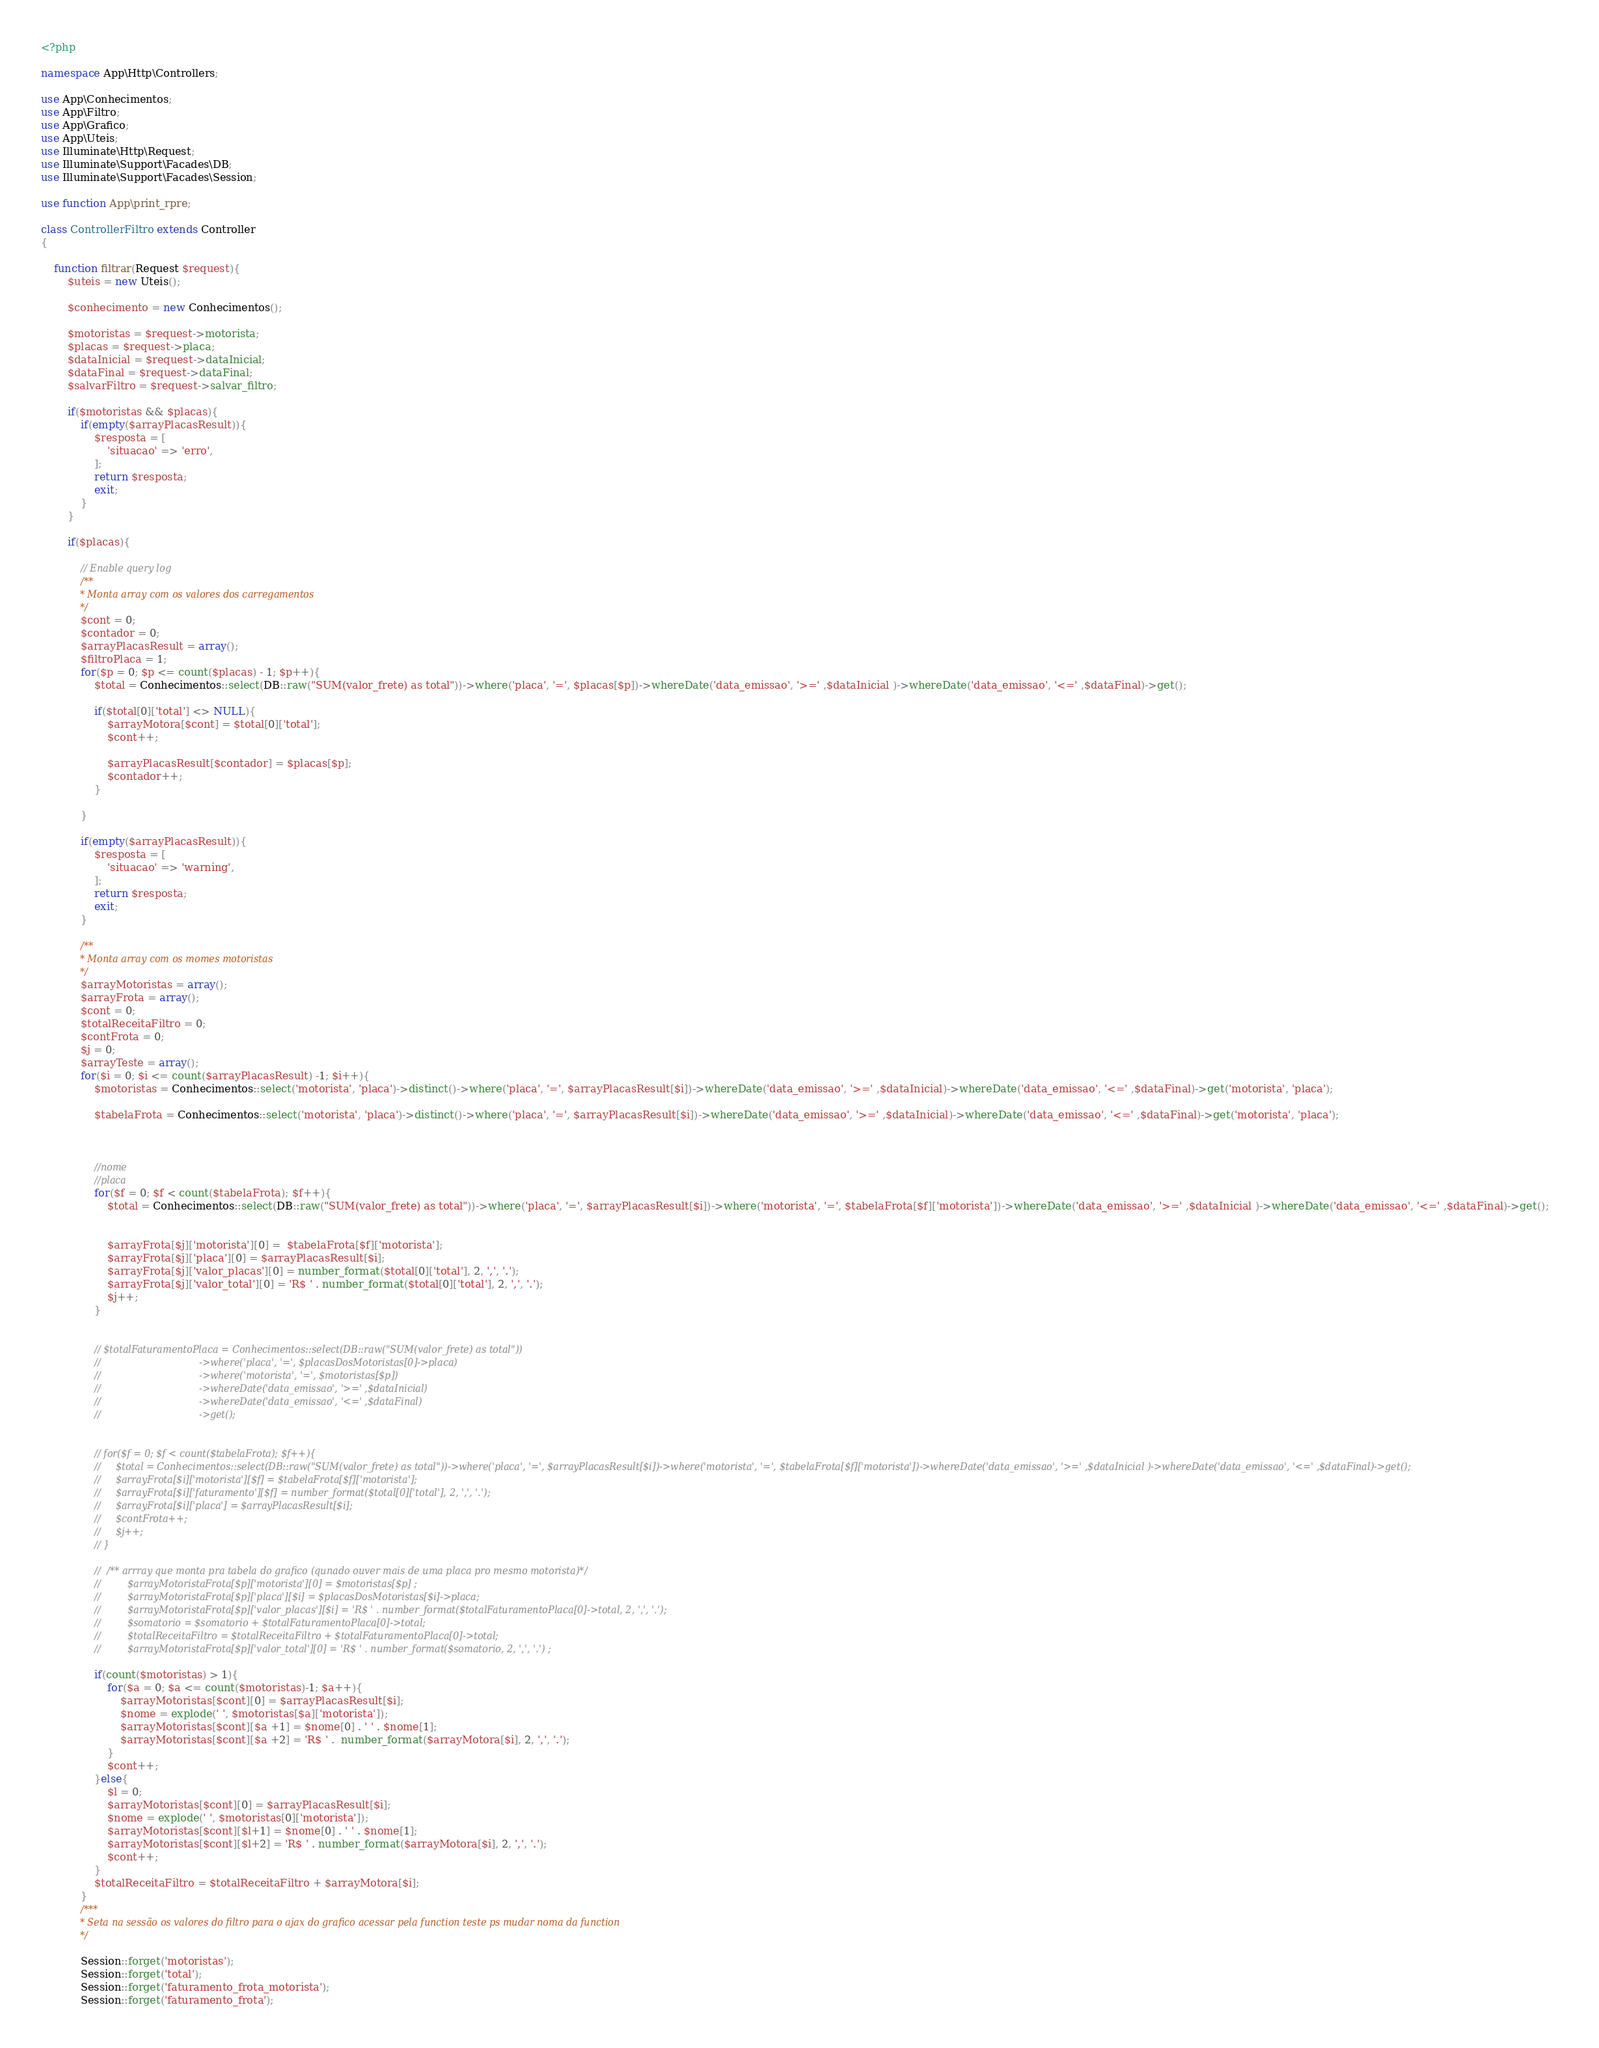Convert code to text. <code><loc_0><loc_0><loc_500><loc_500><_PHP_><?php

namespace App\Http\Controllers;

use App\Conhecimentos;
use App\Filtro;
use App\Grafico;
use App\Uteis;
use Illuminate\Http\Request;
use Illuminate\Support\Facades\DB;
use Illuminate\Support\Facades\Session;

use function App\print_rpre;

class ControllerFiltro extends Controller
{

    function filtrar(Request $request){
        $uteis = new Uteis();

        $conhecimento = new Conhecimentos();

        $motoristas = $request->motorista;
        $placas = $request->placa;
        $dataInicial = $request->dataInicial;
        $dataFinal = $request->dataFinal;
        $salvarFiltro = $request->salvar_filtro;

        if($motoristas && $placas){
            if(empty($arrayPlacasResult)){
                $resposta = [
                    'situacao' => 'erro',
                ];
                return $resposta;
                exit;
            }
        }

        if($placas){

            // Enable query log
            /**
             * Monta array com os valores dos carregamentos
             */
            $cont = 0;
            $contador = 0;
            $arrayPlacasResult = array();
            $filtroPlaca = 1;
            for($p = 0; $p <= count($placas) - 1; $p++){
                $total = Conhecimentos::select(DB::raw("SUM(valor_frete) as total"))->where('placa', '=', $placas[$p])->whereDate('data_emissao', '>=' ,$dataInicial )->whereDate('data_emissao', '<=' ,$dataFinal)->get();

                if($total[0]['total'] <> NULL){
                    $arrayMotora[$cont] = $total[0]['total'];
                    $cont++;

                    $arrayPlacasResult[$contador] = $placas[$p];
                    $contador++;
                }

            }

            if(empty($arrayPlacasResult)){
                $resposta = [
                    'situacao' => 'warning',
                ];
                return $resposta;
                exit;
            }

            /**
             * Monta array com os momes motoristas
             */
            $arrayMotoristas = array();
            $arrayFrota = array();
            $cont = 0;
            $totalReceitaFiltro = 0;
            $contFrota = 0;
            $j = 0;
            $arrayTeste = array();
            for($i = 0; $i <= count($arrayPlacasResult) -1; $i++){
                $motoristas = Conhecimentos::select('motorista', 'placa')->distinct()->where('placa', '=', $arrayPlacasResult[$i])->whereDate('data_emissao', '>=' ,$dataInicial)->whereDate('data_emissao', '<=' ,$dataFinal)->get('motorista', 'placa');

                $tabelaFrota = Conhecimentos::select('motorista', 'placa')->distinct()->where('placa', '=', $arrayPlacasResult[$i])->whereDate('data_emissao', '>=' ,$dataInicial)->whereDate('data_emissao', '<=' ,$dataFinal)->get('motorista', 'placa');



                //nome
                //placa
                for($f = 0; $f < count($tabelaFrota); $f++){
                    $total = Conhecimentos::select(DB::raw("SUM(valor_frete) as total"))->where('placa', '=', $arrayPlacasResult[$i])->where('motorista', '=', $tabelaFrota[$f]['motorista'])->whereDate('data_emissao', '>=' ,$dataInicial )->whereDate('data_emissao', '<=' ,$dataFinal)->get();


                    $arrayFrota[$j]['motorista'][0] =  $tabelaFrota[$f]['motorista'];
                    $arrayFrota[$j]['placa'][0] = $arrayPlacasResult[$i];
                    $arrayFrota[$j]['valor_placas'][0] = number_format($total[0]['total'], 2, ',', '.');
                    $arrayFrota[$j]['valor_total'][0] = 'R$ ' . number_format($total[0]['total'], 2, ',', '.');
                    $j++;
                }


                // $totalFaturamentoPlaca = Conhecimentos::select(DB::raw("SUM(valor_frete) as total"))
                //                                 ->where('placa', '=', $placasDosMotoristas[0]->placa)
                //                                 ->where('motorista', '=', $motoristas[$p])
                //                                 ->whereDate('data_emissao', '>=' ,$dataInicial)
                //                                 ->whereDate('data_emissao', '<=' ,$dataFinal)
                //                                 ->get();


                // for($f = 0; $f < count($tabelaFrota); $f++){
                //     $total = Conhecimentos::select(DB::raw("SUM(valor_frete) as total"))->where('placa', '=', $arrayPlacasResult[$i])->where('motorista', '=', $tabelaFrota[$f]['motorista'])->whereDate('data_emissao', '>=' ,$dataInicial )->whereDate('data_emissao', '<=' ,$dataFinal)->get();
                //     $arrayFrota[$i]['motorista'][$f] = $tabelaFrota[$f]['motorista'];
                //     $arrayFrota[$i]['faturamento'][$f] = number_format($total[0]['total'], 2, ',', '.');
                //     $arrayFrota[$i]['placa'] = $arrayPlacasResult[$i];
                //     $contFrota++;
                //     $j++;
                // }

                //  /** arrray que monta pra tabela do grafico (qunado ouver mais de uma placa pro mesmo motorista)*/
                //         $arrayMotoristaFrota[$p]['motorista'][0] = $motoristas[$p] ;
                //         $arrayMotoristaFrota[$p]['placa'][$i] = $placasDosMotoristas[$i]->placa;
                //         $arrayMotoristaFrota[$p]['valor_placas'][$i] = 'R$ ' . number_format($totalFaturamentoPlaca[0]->total, 2, ',', '.');
                //         $somatorio = $somatorio + $totalFaturamentoPlaca[0]->total;
                //         $totalReceitaFiltro = $totalReceitaFiltro + $totalFaturamentoPlaca[0]->total;
                //         $arrayMotoristaFrota[$p]['valor_total'][0] = 'R$ ' . number_format($somatorio, 2, ',', '.') ;

                if(count($motoristas) > 1){
                    for($a = 0; $a <= count($motoristas)-1; $a++){
                        $arrayMotoristas[$cont][0] = $arrayPlacasResult[$i];
                        $nome = explode(' ', $motoristas[$a]['motorista']);
                        $arrayMotoristas[$cont][$a +1] = $nome[0] . ' ' . $nome[1];
                        $arrayMotoristas[$cont][$a +2] = 'R$ ' .  number_format($arrayMotora[$i], 2, ',', '.');
                    }
                    $cont++;
                }else{
                    $l = 0;
                    $arrayMotoristas[$cont][0] = $arrayPlacasResult[$i];
                    $nome = explode(' ', $motoristas[0]['motorista']);
                    $arrayMotoristas[$cont][$l+1] = $nome[0] . ' ' . $nome[1];
                    $arrayMotoristas[$cont][$l+2] = 'R$ ' . number_format($arrayMotora[$i], 2, ',', '.');
                    $cont++;
                }
                $totalReceitaFiltro = $totalReceitaFiltro + $arrayMotora[$i];
            }
            /***
             * Seta na sessão os valores do filtro para o ajax do grafico acessar pela function teste ps mudar noma da function
             */

            Session::forget('motoristas');
            Session::forget('total');
            Session::forget('faturamento_frota_motorista');
            Session::forget('faturamento_frota');</code> 